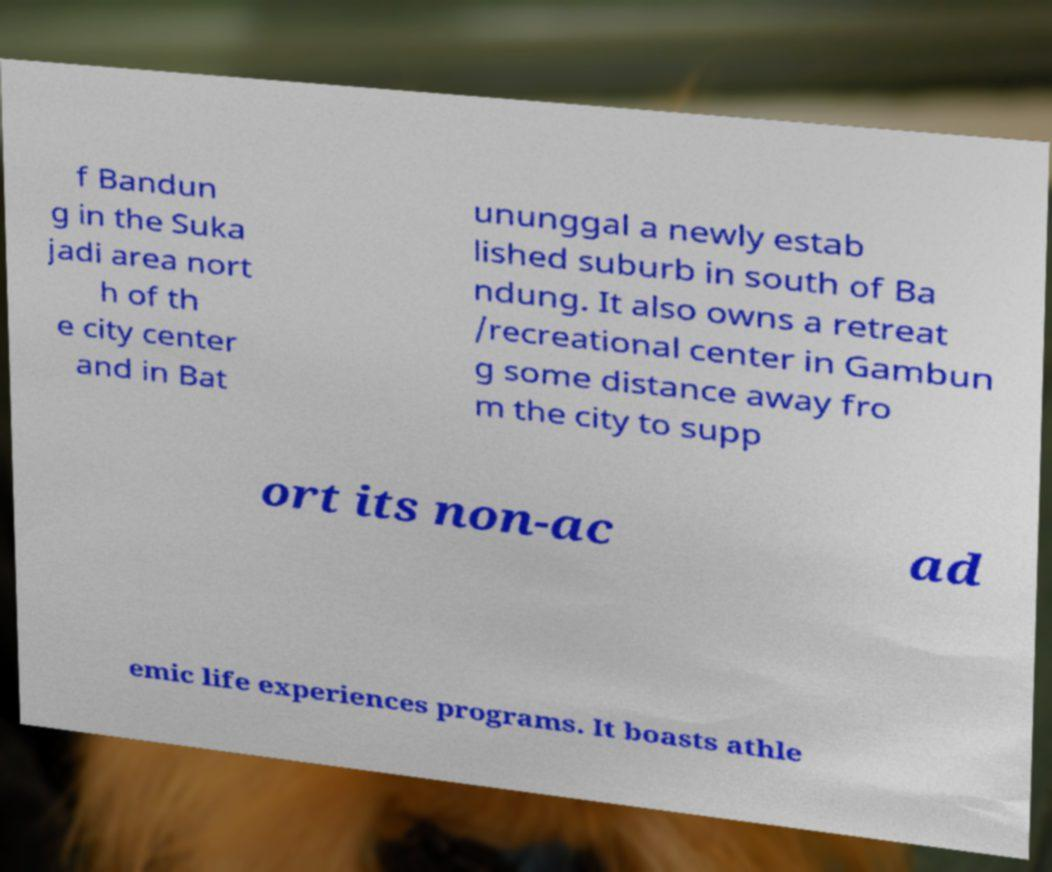Please identify and transcribe the text found in this image. f Bandun g in the Suka jadi area nort h of th e city center and in Bat ununggal a newly estab lished suburb in south of Ba ndung. It also owns a retreat /recreational center in Gambun g some distance away fro m the city to supp ort its non-ac ad emic life experiences programs. It boasts athle 